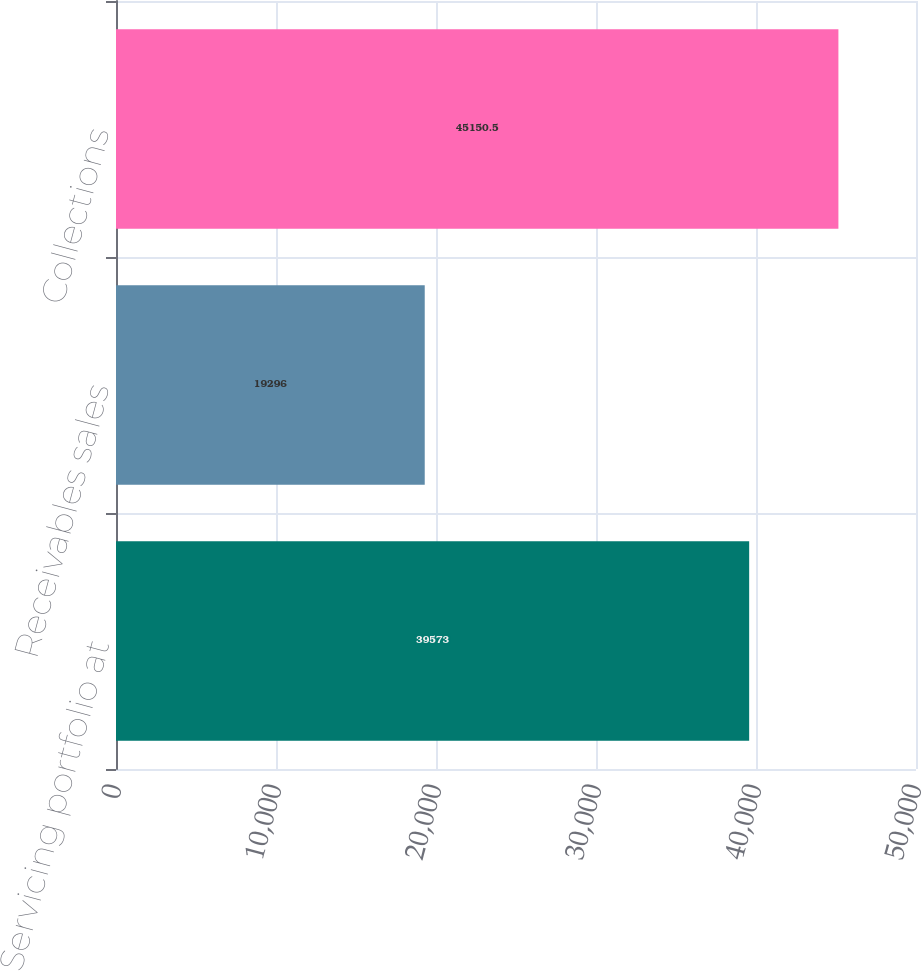Convert chart to OTSL. <chart><loc_0><loc_0><loc_500><loc_500><bar_chart><fcel>Servicing portfolio at<fcel>Receivables sales<fcel>Collections<nl><fcel>39573<fcel>19296<fcel>45150.5<nl></chart> 